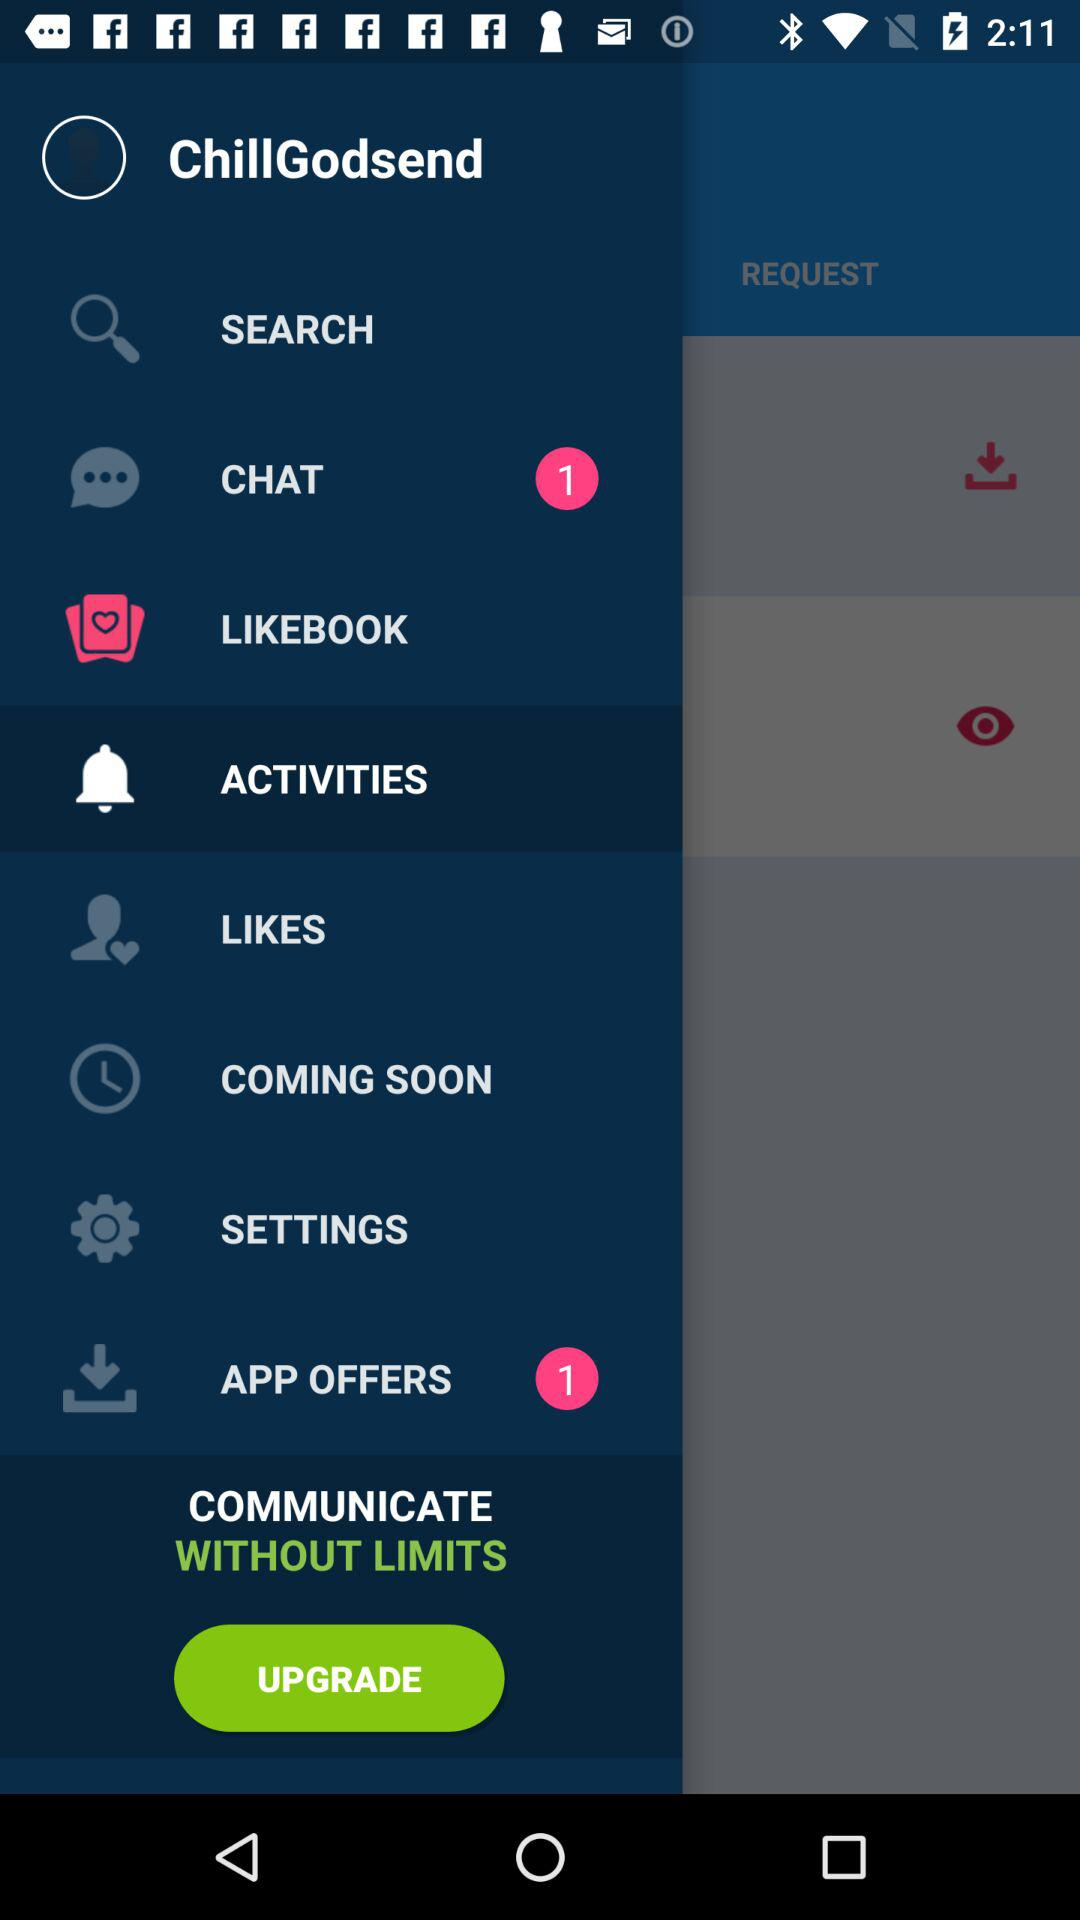How many items have a pink circle with a number 1 in it?
Answer the question using a single word or phrase. 2 